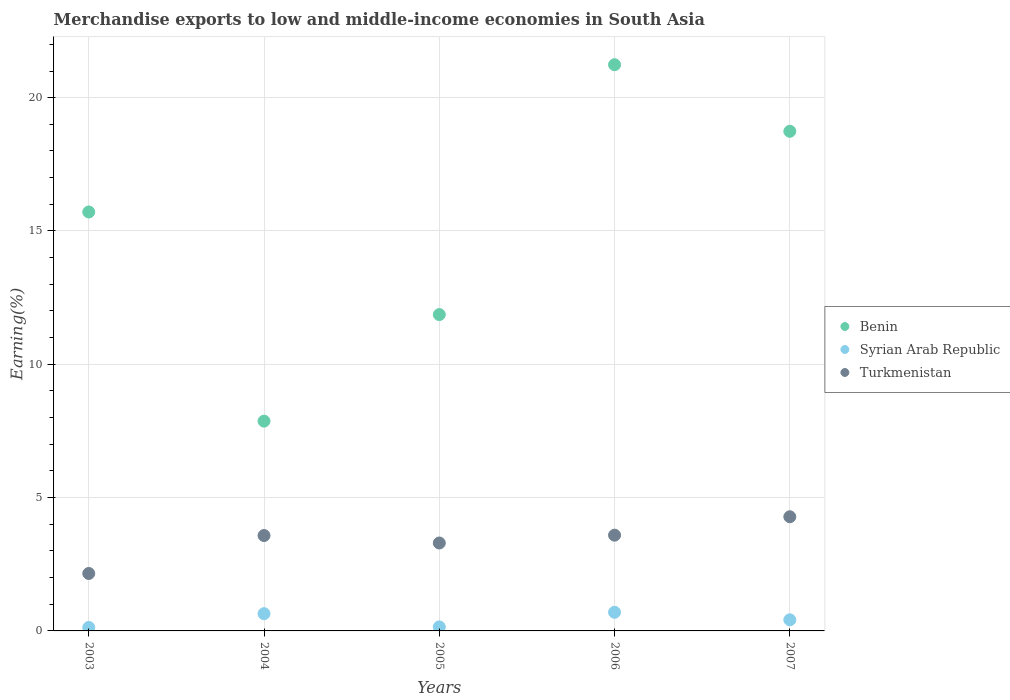How many different coloured dotlines are there?
Provide a short and direct response. 3. What is the percentage of amount earned from merchandise exports in Syrian Arab Republic in 2006?
Offer a terse response. 0.7. Across all years, what is the maximum percentage of amount earned from merchandise exports in Benin?
Your answer should be very brief. 21.24. Across all years, what is the minimum percentage of amount earned from merchandise exports in Turkmenistan?
Offer a very short reply. 2.15. What is the total percentage of amount earned from merchandise exports in Syrian Arab Republic in the graph?
Your answer should be compact. 2.04. What is the difference between the percentage of amount earned from merchandise exports in Benin in 2004 and that in 2007?
Provide a short and direct response. -10.87. What is the difference between the percentage of amount earned from merchandise exports in Benin in 2006 and the percentage of amount earned from merchandise exports in Syrian Arab Republic in 2004?
Your response must be concise. 20.59. What is the average percentage of amount earned from merchandise exports in Benin per year?
Keep it short and to the point. 15.08. In the year 2007, what is the difference between the percentage of amount earned from merchandise exports in Benin and percentage of amount earned from merchandise exports in Turkmenistan?
Your answer should be very brief. 14.46. In how many years, is the percentage of amount earned from merchandise exports in Turkmenistan greater than 16 %?
Your response must be concise. 0. What is the ratio of the percentage of amount earned from merchandise exports in Benin in 2004 to that in 2005?
Keep it short and to the point. 0.66. Is the percentage of amount earned from merchandise exports in Benin in 2005 less than that in 2006?
Provide a succinct answer. Yes. What is the difference between the highest and the second highest percentage of amount earned from merchandise exports in Syrian Arab Republic?
Ensure brevity in your answer.  0.05. What is the difference between the highest and the lowest percentage of amount earned from merchandise exports in Benin?
Give a very brief answer. 13.37. Is the sum of the percentage of amount earned from merchandise exports in Benin in 2005 and 2007 greater than the maximum percentage of amount earned from merchandise exports in Syrian Arab Republic across all years?
Offer a terse response. Yes. Does the percentage of amount earned from merchandise exports in Syrian Arab Republic monotonically increase over the years?
Your answer should be very brief. No. How many years are there in the graph?
Make the answer very short. 5. Are the values on the major ticks of Y-axis written in scientific E-notation?
Your answer should be compact. No. Does the graph contain any zero values?
Offer a terse response. No. How are the legend labels stacked?
Ensure brevity in your answer.  Vertical. What is the title of the graph?
Offer a terse response. Merchandise exports to low and middle-income economies in South Asia. Does "Sub-Saharan Africa (developing only)" appear as one of the legend labels in the graph?
Ensure brevity in your answer.  No. What is the label or title of the Y-axis?
Offer a terse response. Earning(%). What is the Earning(%) in Benin in 2003?
Your response must be concise. 15.71. What is the Earning(%) of Syrian Arab Republic in 2003?
Offer a terse response. 0.13. What is the Earning(%) of Turkmenistan in 2003?
Offer a very short reply. 2.15. What is the Earning(%) in Benin in 2004?
Keep it short and to the point. 7.87. What is the Earning(%) in Syrian Arab Republic in 2004?
Your response must be concise. 0.65. What is the Earning(%) in Turkmenistan in 2004?
Make the answer very short. 3.58. What is the Earning(%) in Benin in 2005?
Give a very brief answer. 11.86. What is the Earning(%) in Syrian Arab Republic in 2005?
Offer a terse response. 0.15. What is the Earning(%) in Turkmenistan in 2005?
Your answer should be compact. 3.3. What is the Earning(%) of Benin in 2006?
Provide a short and direct response. 21.24. What is the Earning(%) in Syrian Arab Republic in 2006?
Give a very brief answer. 0.7. What is the Earning(%) of Turkmenistan in 2006?
Offer a terse response. 3.59. What is the Earning(%) in Benin in 2007?
Give a very brief answer. 18.74. What is the Earning(%) in Syrian Arab Republic in 2007?
Offer a very short reply. 0.42. What is the Earning(%) of Turkmenistan in 2007?
Ensure brevity in your answer.  4.28. Across all years, what is the maximum Earning(%) of Benin?
Ensure brevity in your answer.  21.24. Across all years, what is the maximum Earning(%) in Syrian Arab Republic?
Offer a terse response. 0.7. Across all years, what is the maximum Earning(%) of Turkmenistan?
Your response must be concise. 4.28. Across all years, what is the minimum Earning(%) of Benin?
Your answer should be very brief. 7.87. Across all years, what is the minimum Earning(%) of Syrian Arab Republic?
Give a very brief answer. 0.13. Across all years, what is the minimum Earning(%) in Turkmenistan?
Offer a terse response. 2.15. What is the total Earning(%) in Benin in the graph?
Provide a short and direct response. 75.42. What is the total Earning(%) in Syrian Arab Republic in the graph?
Provide a succinct answer. 2.04. What is the total Earning(%) in Turkmenistan in the graph?
Your response must be concise. 16.9. What is the difference between the Earning(%) in Benin in 2003 and that in 2004?
Provide a short and direct response. 7.84. What is the difference between the Earning(%) of Syrian Arab Republic in 2003 and that in 2004?
Ensure brevity in your answer.  -0.52. What is the difference between the Earning(%) of Turkmenistan in 2003 and that in 2004?
Offer a very short reply. -1.42. What is the difference between the Earning(%) in Benin in 2003 and that in 2005?
Make the answer very short. 3.85. What is the difference between the Earning(%) in Syrian Arab Republic in 2003 and that in 2005?
Ensure brevity in your answer.  -0.02. What is the difference between the Earning(%) of Turkmenistan in 2003 and that in 2005?
Offer a terse response. -1.14. What is the difference between the Earning(%) in Benin in 2003 and that in 2006?
Give a very brief answer. -5.52. What is the difference between the Earning(%) of Syrian Arab Republic in 2003 and that in 2006?
Offer a very short reply. -0.57. What is the difference between the Earning(%) of Turkmenistan in 2003 and that in 2006?
Make the answer very short. -1.44. What is the difference between the Earning(%) in Benin in 2003 and that in 2007?
Offer a terse response. -3.03. What is the difference between the Earning(%) of Syrian Arab Republic in 2003 and that in 2007?
Offer a terse response. -0.29. What is the difference between the Earning(%) of Turkmenistan in 2003 and that in 2007?
Ensure brevity in your answer.  -2.13. What is the difference between the Earning(%) of Benin in 2004 and that in 2005?
Your answer should be very brief. -4. What is the difference between the Earning(%) of Syrian Arab Republic in 2004 and that in 2005?
Keep it short and to the point. 0.5. What is the difference between the Earning(%) of Turkmenistan in 2004 and that in 2005?
Give a very brief answer. 0.28. What is the difference between the Earning(%) in Benin in 2004 and that in 2006?
Provide a short and direct response. -13.37. What is the difference between the Earning(%) of Syrian Arab Republic in 2004 and that in 2006?
Provide a succinct answer. -0.05. What is the difference between the Earning(%) of Turkmenistan in 2004 and that in 2006?
Provide a succinct answer. -0.01. What is the difference between the Earning(%) in Benin in 2004 and that in 2007?
Offer a very short reply. -10.87. What is the difference between the Earning(%) in Syrian Arab Republic in 2004 and that in 2007?
Make the answer very short. 0.23. What is the difference between the Earning(%) in Turkmenistan in 2004 and that in 2007?
Your answer should be very brief. -0.7. What is the difference between the Earning(%) in Benin in 2005 and that in 2006?
Your answer should be very brief. -9.37. What is the difference between the Earning(%) in Syrian Arab Republic in 2005 and that in 2006?
Your response must be concise. -0.55. What is the difference between the Earning(%) of Turkmenistan in 2005 and that in 2006?
Give a very brief answer. -0.29. What is the difference between the Earning(%) in Benin in 2005 and that in 2007?
Make the answer very short. -6.87. What is the difference between the Earning(%) in Syrian Arab Republic in 2005 and that in 2007?
Your answer should be compact. -0.27. What is the difference between the Earning(%) in Turkmenistan in 2005 and that in 2007?
Your response must be concise. -0.98. What is the difference between the Earning(%) in Benin in 2006 and that in 2007?
Offer a very short reply. 2.5. What is the difference between the Earning(%) of Syrian Arab Republic in 2006 and that in 2007?
Provide a succinct answer. 0.28. What is the difference between the Earning(%) in Turkmenistan in 2006 and that in 2007?
Your answer should be very brief. -0.69. What is the difference between the Earning(%) in Benin in 2003 and the Earning(%) in Syrian Arab Republic in 2004?
Keep it short and to the point. 15.07. What is the difference between the Earning(%) in Benin in 2003 and the Earning(%) in Turkmenistan in 2004?
Keep it short and to the point. 12.13. What is the difference between the Earning(%) in Syrian Arab Republic in 2003 and the Earning(%) in Turkmenistan in 2004?
Offer a very short reply. -3.45. What is the difference between the Earning(%) of Benin in 2003 and the Earning(%) of Syrian Arab Republic in 2005?
Your answer should be compact. 15.56. What is the difference between the Earning(%) in Benin in 2003 and the Earning(%) in Turkmenistan in 2005?
Your response must be concise. 12.41. What is the difference between the Earning(%) in Syrian Arab Republic in 2003 and the Earning(%) in Turkmenistan in 2005?
Ensure brevity in your answer.  -3.17. What is the difference between the Earning(%) in Benin in 2003 and the Earning(%) in Syrian Arab Republic in 2006?
Your answer should be compact. 15.01. What is the difference between the Earning(%) of Benin in 2003 and the Earning(%) of Turkmenistan in 2006?
Give a very brief answer. 12.12. What is the difference between the Earning(%) in Syrian Arab Republic in 2003 and the Earning(%) in Turkmenistan in 2006?
Give a very brief answer. -3.46. What is the difference between the Earning(%) of Benin in 2003 and the Earning(%) of Syrian Arab Republic in 2007?
Offer a very short reply. 15.3. What is the difference between the Earning(%) of Benin in 2003 and the Earning(%) of Turkmenistan in 2007?
Give a very brief answer. 11.43. What is the difference between the Earning(%) in Syrian Arab Republic in 2003 and the Earning(%) in Turkmenistan in 2007?
Your answer should be compact. -4.15. What is the difference between the Earning(%) of Benin in 2004 and the Earning(%) of Syrian Arab Republic in 2005?
Provide a succinct answer. 7.72. What is the difference between the Earning(%) in Benin in 2004 and the Earning(%) in Turkmenistan in 2005?
Offer a very short reply. 4.57. What is the difference between the Earning(%) of Syrian Arab Republic in 2004 and the Earning(%) of Turkmenistan in 2005?
Ensure brevity in your answer.  -2.65. What is the difference between the Earning(%) of Benin in 2004 and the Earning(%) of Syrian Arab Republic in 2006?
Offer a terse response. 7.17. What is the difference between the Earning(%) in Benin in 2004 and the Earning(%) in Turkmenistan in 2006?
Your answer should be very brief. 4.28. What is the difference between the Earning(%) in Syrian Arab Republic in 2004 and the Earning(%) in Turkmenistan in 2006?
Your answer should be compact. -2.94. What is the difference between the Earning(%) of Benin in 2004 and the Earning(%) of Syrian Arab Republic in 2007?
Your answer should be compact. 7.45. What is the difference between the Earning(%) of Benin in 2004 and the Earning(%) of Turkmenistan in 2007?
Your response must be concise. 3.59. What is the difference between the Earning(%) in Syrian Arab Republic in 2004 and the Earning(%) in Turkmenistan in 2007?
Make the answer very short. -3.64. What is the difference between the Earning(%) in Benin in 2005 and the Earning(%) in Syrian Arab Republic in 2006?
Your response must be concise. 11.17. What is the difference between the Earning(%) in Benin in 2005 and the Earning(%) in Turkmenistan in 2006?
Ensure brevity in your answer.  8.27. What is the difference between the Earning(%) in Syrian Arab Republic in 2005 and the Earning(%) in Turkmenistan in 2006?
Give a very brief answer. -3.44. What is the difference between the Earning(%) of Benin in 2005 and the Earning(%) of Syrian Arab Republic in 2007?
Ensure brevity in your answer.  11.45. What is the difference between the Earning(%) in Benin in 2005 and the Earning(%) in Turkmenistan in 2007?
Your response must be concise. 7.58. What is the difference between the Earning(%) of Syrian Arab Republic in 2005 and the Earning(%) of Turkmenistan in 2007?
Your answer should be compact. -4.13. What is the difference between the Earning(%) of Benin in 2006 and the Earning(%) of Syrian Arab Republic in 2007?
Offer a very short reply. 20.82. What is the difference between the Earning(%) in Benin in 2006 and the Earning(%) in Turkmenistan in 2007?
Offer a terse response. 16.95. What is the difference between the Earning(%) in Syrian Arab Republic in 2006 and the Earning(%) in Turkmenistan in 2007?
Provide a short and direct response. -3.58. What is the average Earning(%) in Benin per year?
Ensure brevity in your answer.  15.08. What is the average Earning(%) in Syrian Arab Republic per year?
Give a very brief answer. 0.41. What is the average Earning(%) in Turkmenistan per year?
Your answer should be compact. 3.38. In the year 2003, what is the difference between the Earning(%) of Benin and Earning(%) of Syrian Arab Republic?
Keep it short and to the point. 15.58. In the year 2003, what is the difference between the Earning(%) of Benin and Earning(%) of Turkmenistan?
Make the answer very short. 13.56. In the year 2003, what is the difference between the Earning(%) of Syrian Arab Republic and Earning(%) of Turkmenistan?
Ensure brevity in your answer.  -2.02. In the year 2004, what is the difference between the Earning(%) in Benin and Earning(%) in Syrian Arab Republic?
Offer a terse response. 7.22. In the year 2004, what is the difference between the Earning(%) in Benin and Earning(%) in Turkmenistan?
Provide a short and direct response. 4.29. In the year 2004, what is the difference between the Earning(%) in Syrian Arab Republic and Earning(%) in Turkmenistan?
Your answer should be very brief. -2.93. In the year 2005, what is the difference between the Earning(%) in Benin and Earning(%) in Syrian Arab Republic?
Keep it short and to the point. 11.72. In the year 2005, what is the difference between the Earning(%) of Benin and Earning(%) of Turkmenistan?
Provide a succinct answer. 8.57. In the year 2005, what is the difference between the Earning(%) in Syrian Arab Republic and Earning(%) in Turkmenistan?
Your answer should be compact. -3.15. In the year 2006, what is the difference between the Earning(%) in Benin and Earning(%) in Syrian Arab Republic?
Keep it short and to the point. 20.54. In the year 2006, what is the difference between the Earning(%) in Benin and Earning(%) in Turkmenistan?
Provide a short and direct response. 17.64. In the year 2006, what is the difference between the Earning(%) in Syrian Arab Republic and Earning(%) in Turkmenistan?
Provide a succinct answer. -2.89. In the year 2007, what is the difference between the Earning(%) of Benin and Earning(%) of Syrian Arab Republic?
Offer a terse response. 18.32. In the year 2007, what is the difference between the Earning(%) in Benin and Earning(%) in Turkmenistan?
Ensure brevity in your answer.  14.46. In the year 2007, what is the difference between the Earning(%) in Syrian Arab Republic and Earning(%) in Turkmenistan?
Provide a succinct answer. -3.87. What is the ratio of the Earning(%) of Benin in 2003 to that in 2004?
Make the answer very short. 2. What is the ratio of the Earning(%) of Syrian Arab Republic in 2003 to that in 2004?
Your answer should be compact. 0.2. What is the ratio of the Earning(%) of Turkmenistan in 2003 to that in 2004?
Make the answer very short. 0.6. What is the ratio of the Earning(%) in Benin in 2003 to that in 2005?
Offer a very short reply. 1.32. What is the ratio of the Earning(%) in Syrian Arab Republic in 2003 to that in 2005?
Provide a short and direct response. 0.86. What is the ratio of the Earning(%) of Turkmenistan in 2003 to that in 2005?
Provide a short and direct response. 0.65. What is the ratio of the Earning(%) of Benin in 2003 to that in 2006?
Your answer should be compact. 0.74. What is the ratio of the Earning(%) in Syrian Arab Republic in 2003 to that in 2006?
Offer a very short reply. 0.19. What is the ratio of the Earning(%) of Turkmenistan in 2003 to that in 2006?
Your response must be concise. 0.6. What is the ratio of the Earning(%) of Benin in 2003 to that in 2007?
Offer a very short reply. 0.84. What is the ratio of the Earning(%) in Syrian Arab Republic in 2003 to that in 2007?
Give a very brief answer. 0.31. What is the ratio of the Earning(%) in Turkmenistan in 2003 to that in 2007?
Offer a terse response. 0.5. What is the ratio of the Earning(%) in Benin in 2004 to that in 2005?
Provide a short and direct response. 0.66. What is the ratio of the Earning(%) of Syrian Arab Republic in 2004 to that in 2005?
Keep it short and to the point. 4.31. What is the ratio of the Earning(%) in Turkmenistan in 2004 to that in 2005?
Provide a short and direct response. 1.08. What is the ratio of the Earning(%) of Benin in 2004 to that in 2006?
Make the answer very short. 0.37. What is the ratio of the Earning(%) of Syrian Arab Republic in 2004 to that in 2006?
Your answer should be very brief. 0.92. What is the ratio of the Earning(%) of Turkmenistan in 2004 to that in 2006?
Provide a succinct answer. 1. What is the ratio of the Earning(%) of Benin in 2004 to that in 2007?
Provide a short and direct response. 0.42. What is the ratio of the Earning(%) of Syrian Arab Republic in 2004 to that in 2007?
Provide a short and direct response. 1.55. What is the ratio of the Earning(%) in Turkmenistan in 2004 to that in 2007?
Ensure brevity in your answer.  0.84. What is the ratio of the Earning(%) in Benin in 2005 to that in 2006?
Keep it short and to the point. 0.56. What is the ratio of the Earning(%) of Syrian Arab Republic in 2005 to that in 2006?
Give a very brief answer. 0.21. What is the ratio of the Earning(%) of Turkmenistan in 2005 to that in 2006?
Offer a very short reply. 0.92. What is the ratio of the Earning(%) in Benin in 2005 to that in 2007?
Give a very brief answer. 0.63. What is the ratio of the Earning(%) of Syrian Arab Republic in 2005 to that in 2007?
Offer a terse response. 0.36. What is the ratio of the Earning(%) of Turkmenistan in 2005 to that in 2007?
Your answer should be very brief. 0.77. What is the ratio of the Earning(%) of Benin in 2006 to that in 2007?
Your response must be concise. 1.13. What is the ratio of the Earning(%) of Syrian Arab Republic in 2006 to that in 2007?
Your response must be concise. 1.68. What is the ratio of the Earning(%) in Turkmenistan in 2006 to that in 2007?
Give a very brief answer. 0.84. What is the difference between the highest and the second highest Earning(%) of Benin?
Keep it short and to the point. 2.5. What is the difference between the highest and the second highest Earning(%) of Syrian Arab Republic?
Your response must be concise. 0.05. What is the difference between the highest and the second highest Earning(%) in Turkmenistan?
Your answer should be very brief. 0.69. What is the difference between the highest and the lowest Earning(%) of Benin?
Make the answer very short. 13.37. What is the difference between the highest and the lowest Earning(%) of Syrian Arab Republic?
Provide a succinct answer. 0.57. What is the difference between the highest and the lowest Earning(%) in Turkmenistan?
Keep it short and to the point. 2.13. 